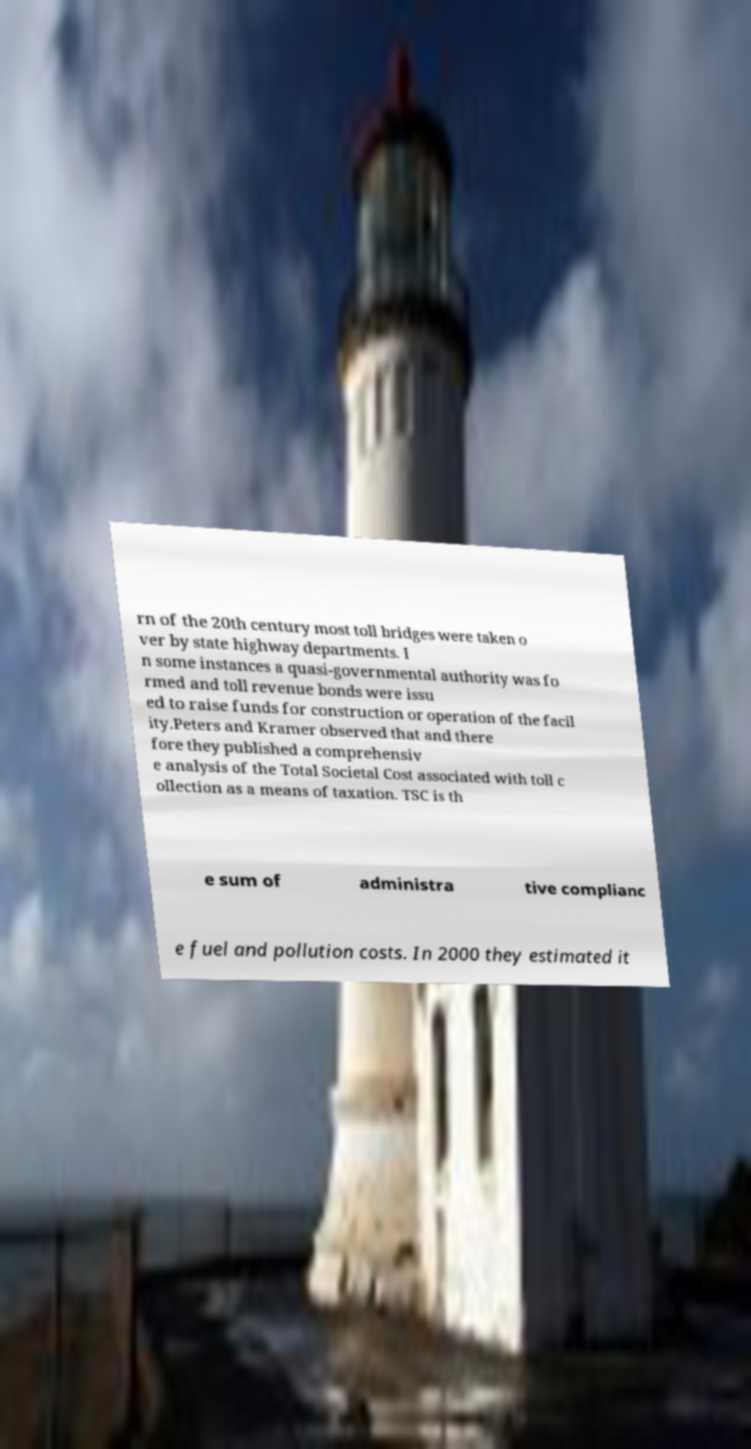Please identify and transcribe the text found in this image. rn of the 20th century most toll bridges were taken o ver by state highway departments. I n some instances a quasi-governmental authority was fo rmed and toll revenue bonds were issu ed to raise funds for construction or operation of the facil ity.Peters and Kramer observed that and there fore they published a comprehensiv e analysis of the Total Societal Cost associated with toll c ollection as a means of taxation. TSC is th e sum of administra tive complianc e fuel and pollution costs. In 2000 they estimated it 